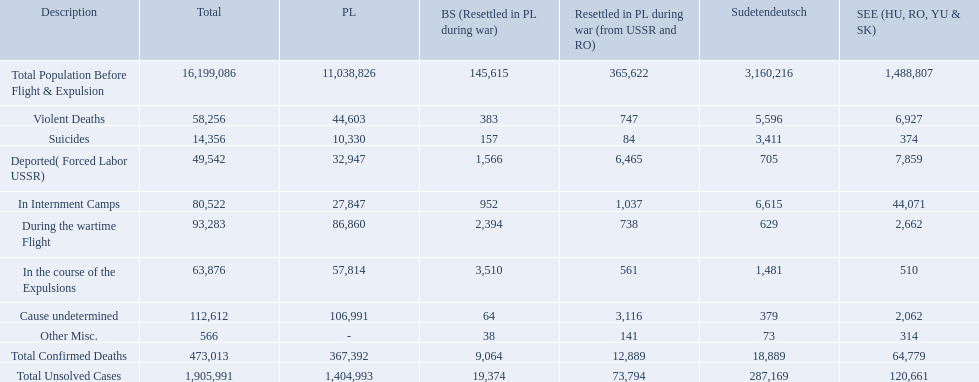How many total confirmed deaths were there in the baltic states? 9,064. How many deaths had an undetermined cause? 64. How many deaths in that region were miscellaneous? 38. Were there more deaths from an undetermined cause or that were listed as miscellaneous? Cause undetermined. How many deaths did the baltic states have in each category? 145,615, 383, 157, 1,566, 952, 2,394, 3,510, 64, 38, 9,064, 19,374. How many cause undetermined deaths did baltic states have? 64. How many other miscellaneous deaths did baltic states have? 38. Which is higher in deaths, cause undetermined or other miscellaneous? Cause undetermined. 